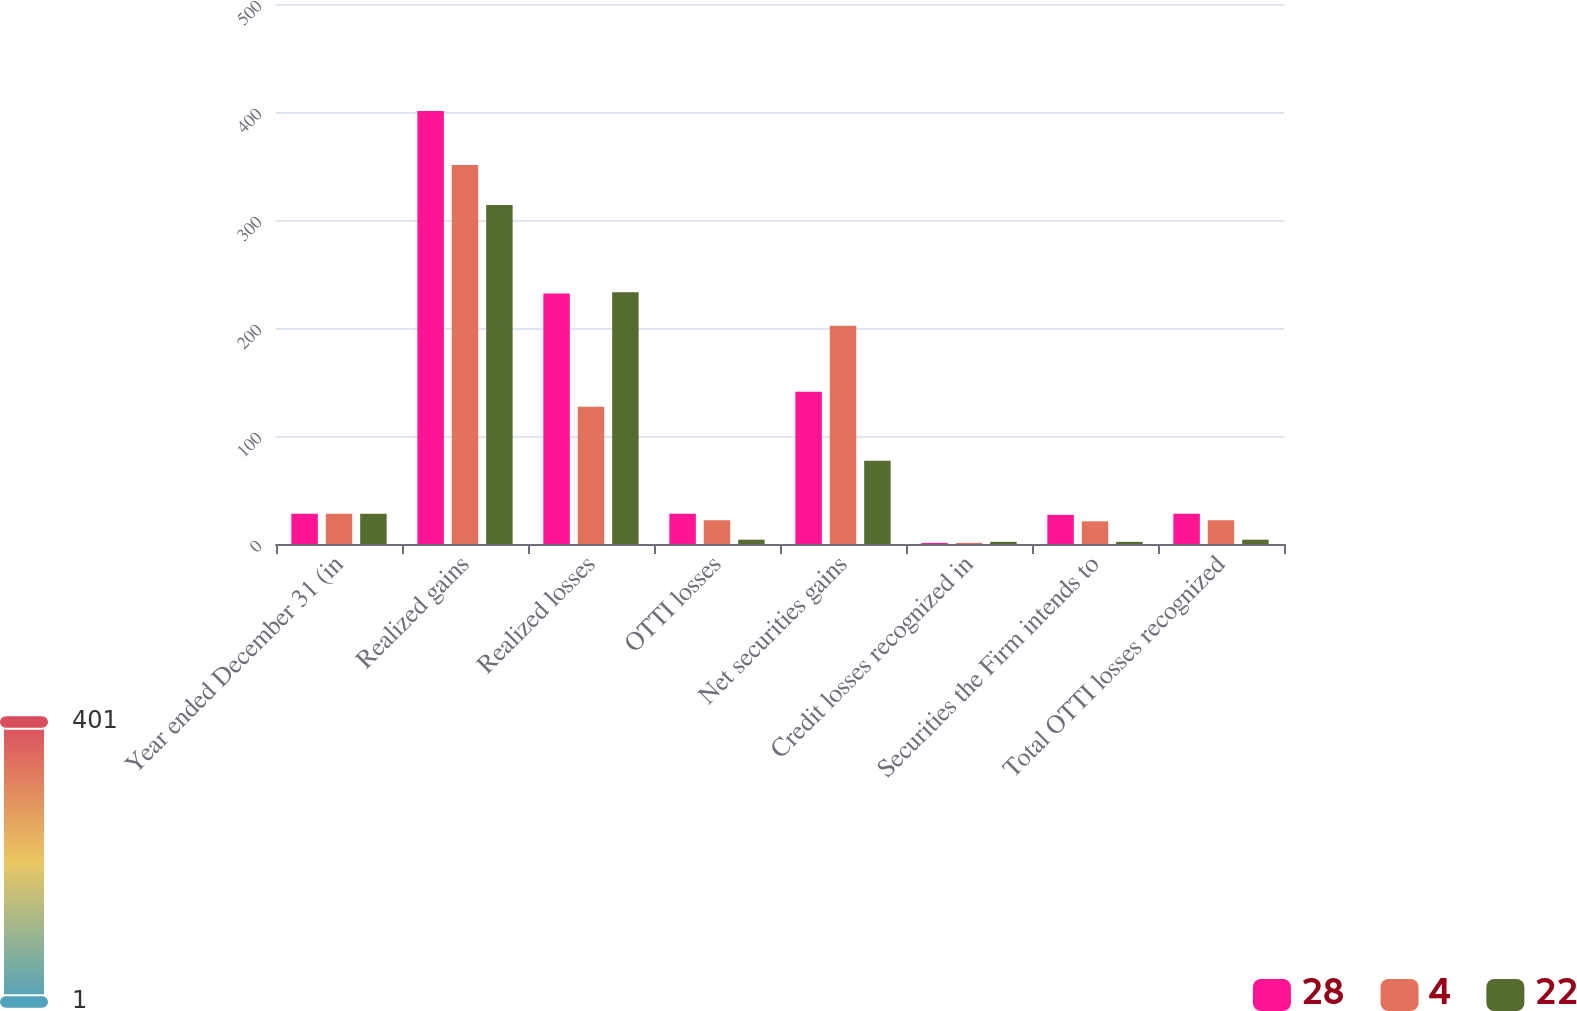Convert chart to OTSL. <chart><loc_0><loc_0><loc_500><loc_500><stacked_bar_chart><ecel><fcel>Year ended December 31 (in<fcel>Realized gains<fcel>Realized losses<fcel>OTTI losses<fcel>Net securities gains<fcel>Credit losses recognized in<fcel>Securities the Firm intends to<fcel>Total OTTI losses recognized<nl><fcel>28<fcel>28<fcel>401<fcel>232<fcel>28<fcel>141<fcel>1<fcel>27<fcel>28<nl><fcel>4<fcel>28<fcel>351<fcel>127<fcel>22<fcel>202<fcel>1<fcel>21<fcel>22<nl><fcel>22<fcel>28<fcel>314<fcel>233<fcel>4<fcel>77<fcel>2<fcel>2<fcel>4<nl></chart> 